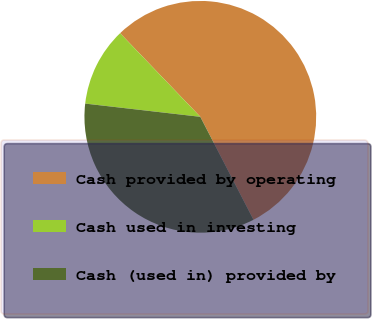Convert chart. <chart><loc_0><loc_0><loc_500><loc_500><pie_chart><fcel>Cash provided by operating<fcel>Cash used in investing<fcel>Cash (used in) provided by<nl><fcel>54.58%<fcel>11.01%<fcel>34.41%<nl></chart> 